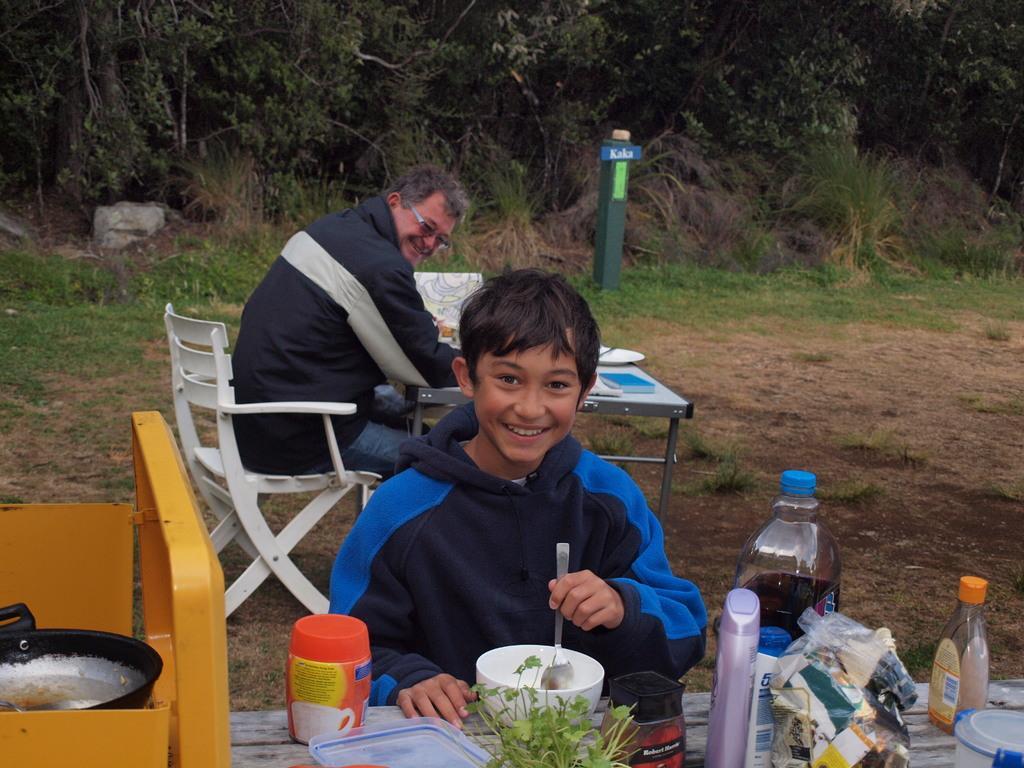Could you give a brief overview of what you see in this image? In the image we can see there is a person who is sitting on chair and in front of him there is a table on which there are bowl, spoon, glass bottle, powder box and a cover and at the back there is another person who is sitting on chair and in front of him there is a table and at the back there are lot of trees. 